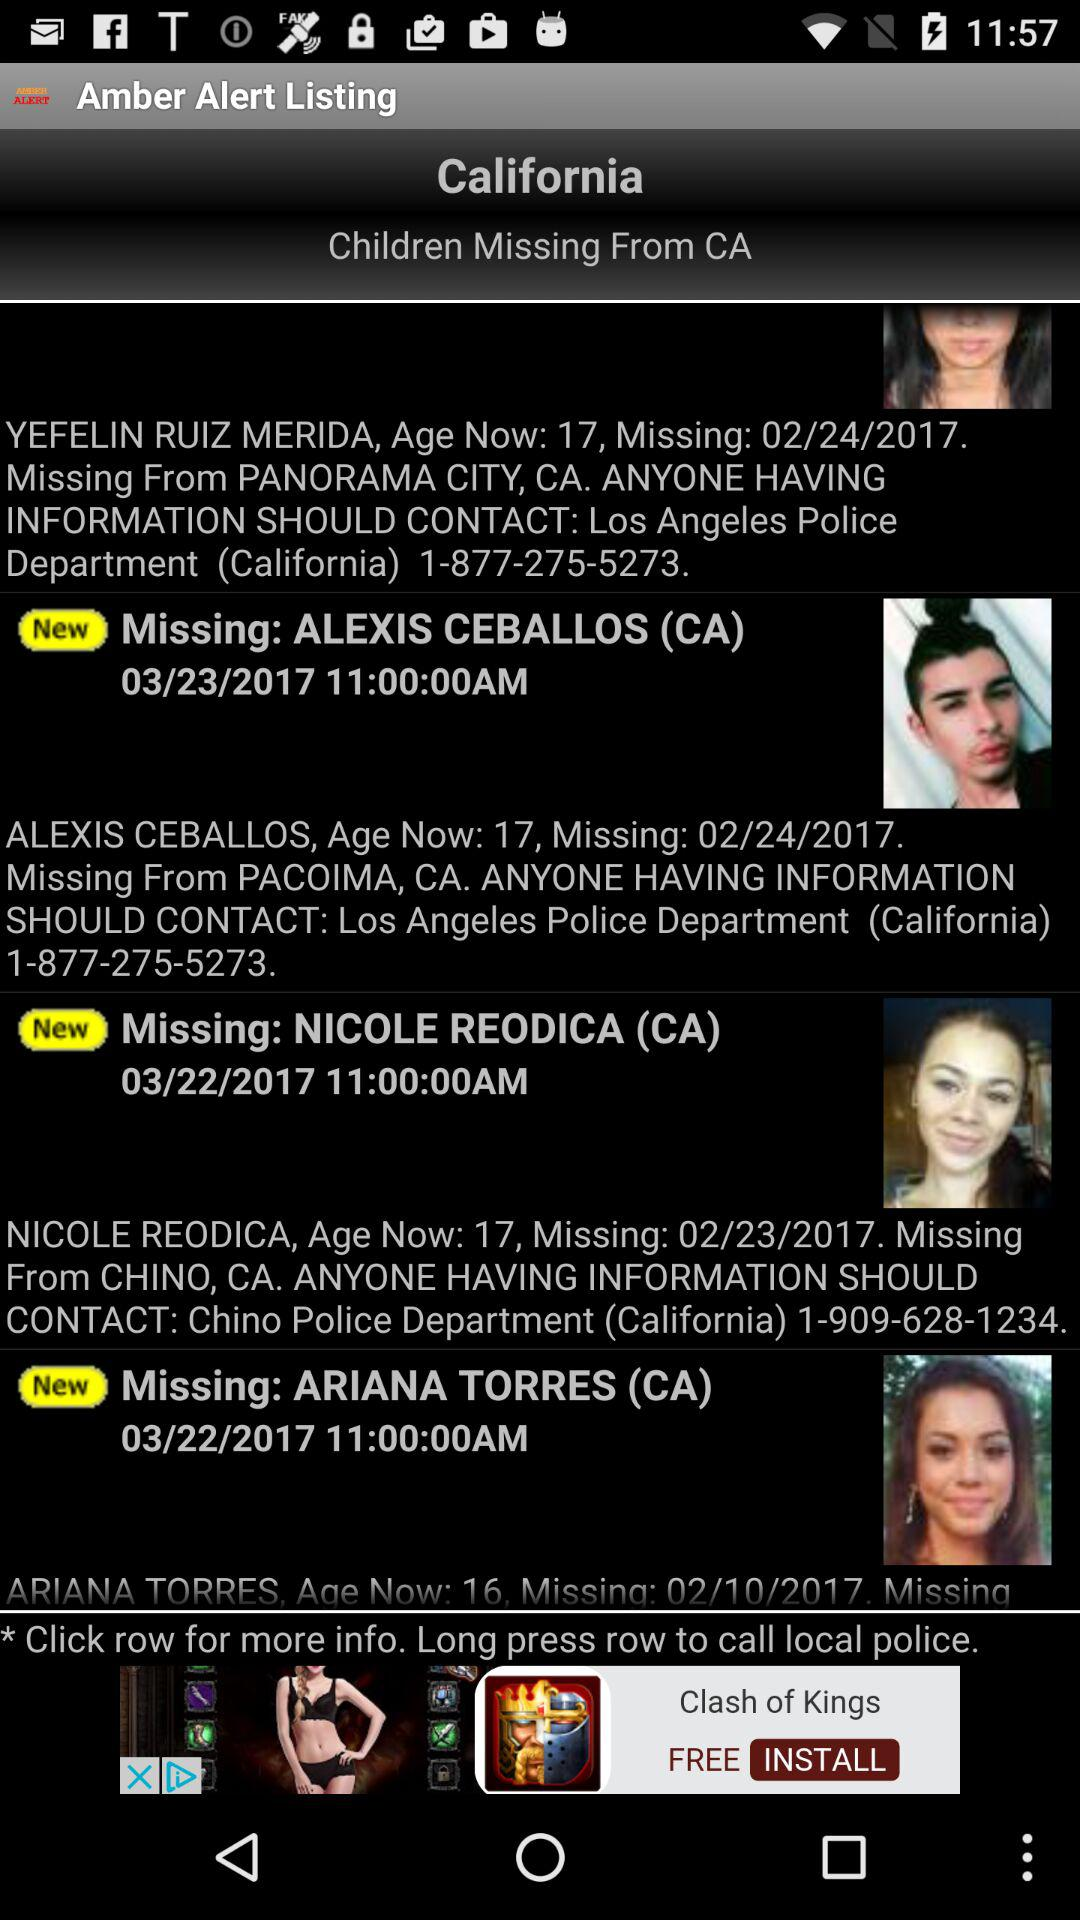What is the contact number for Nicole Reodica? The contact number for Nicole Reodica is 1-909-628-1234. 